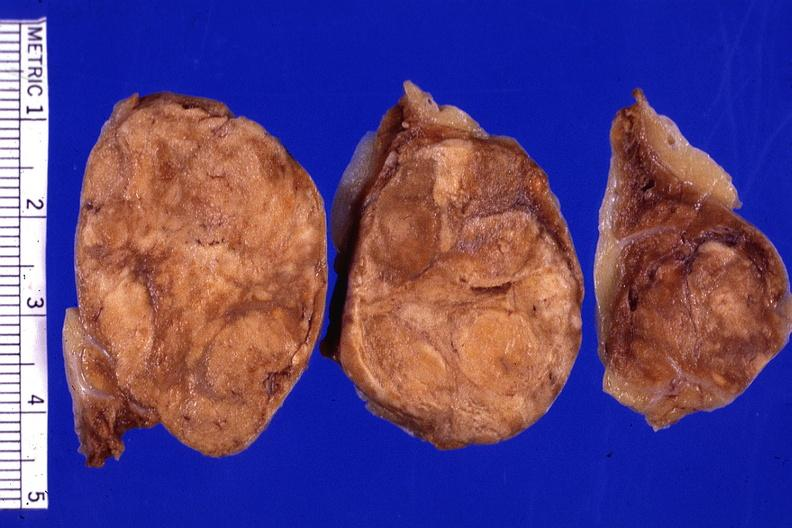s this present?
Answer the question using a single word or phrase. No 